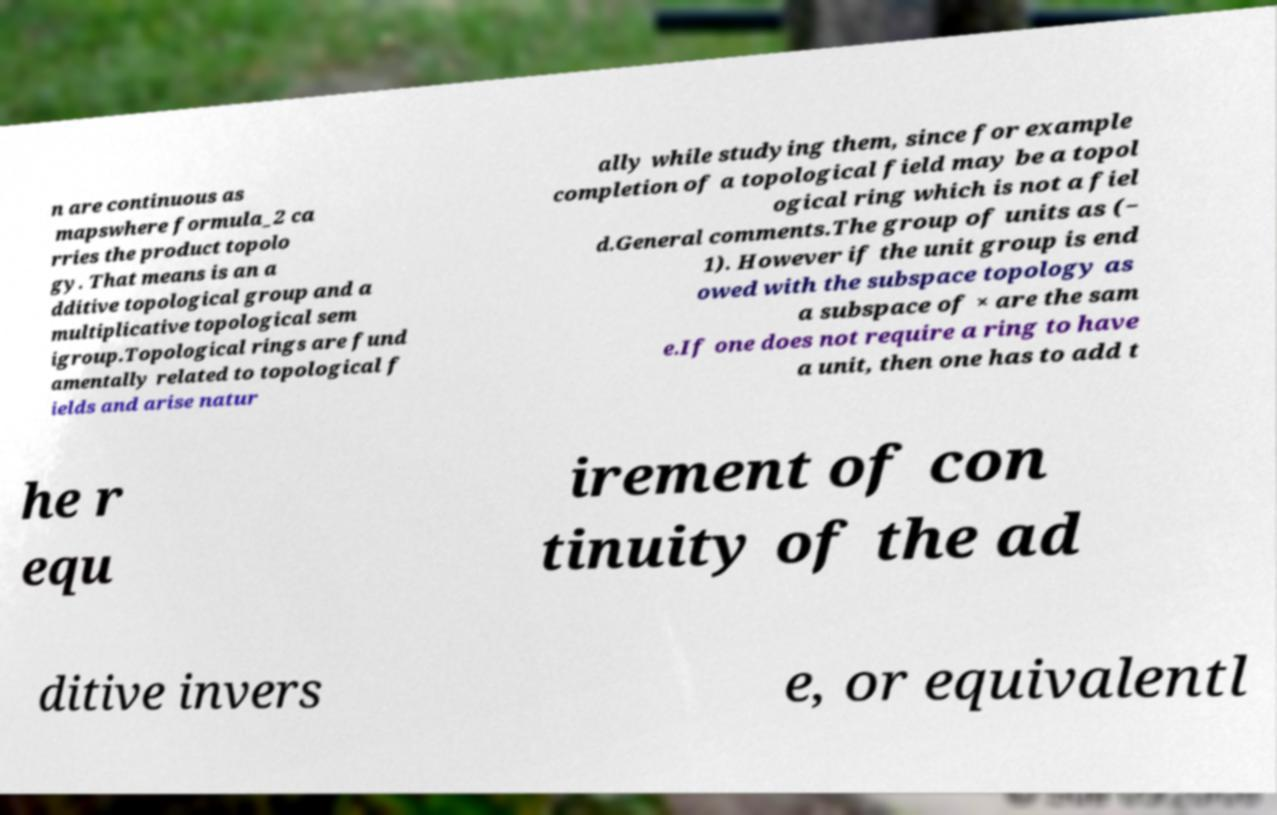What messages or text are displayed in this image? I need them in a readable, typed format. n are continuous as mapswhere formula_2 ca rries the product topolo gy. That means is an a dditive topological group and a multiplicative topological sem igroup.Topological rings are fund amentally related to topological f ields and arise natur ally while studying them, since for example completion of a topological field may be a topol ogical ring which is not a fiel d.General comments.The group of units as (− 1). However if the unit group is end owed with the subspace topology as a subspace of × are the sam e.If one does not require a ring to have a unit, then one has to add t he r equ irement of con tinuity of the ad ditive invers e, or equivalentl 